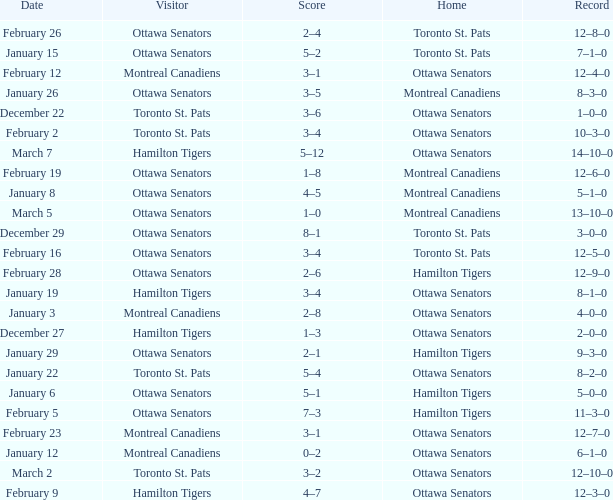Who was the home team when the vistor team was the Montreal Canadiens on February 12? Ottawa Senators. 